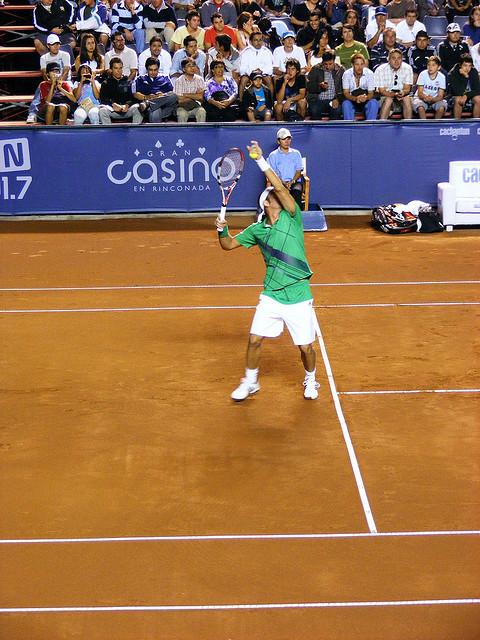What is the tennis player doing with the ball?
Write a very short answer. Serving. What color is the court?
Quick response, please. Brown. What kind of terrain is he playing on?
Write a very short answer. Clay. Who is the advertiser?
Quick response, please. Casino. 